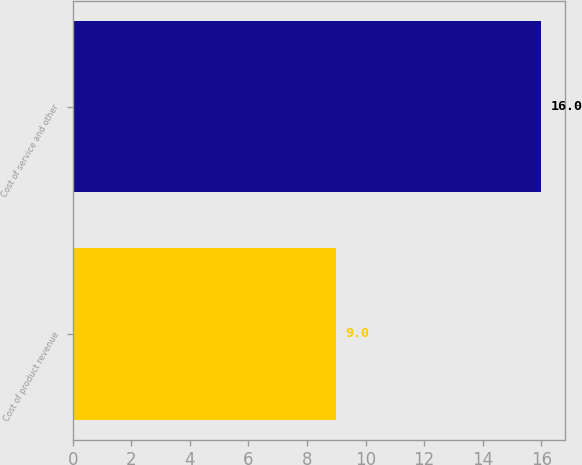Convert chart to OTSL. <chart><loc_0><loc_0><loc_500><loc_500><bar_chart><fcel>Cost of product revenue<fcel>Cost of service and other<nl><fcel>9<fcel>16<nl></chart> 